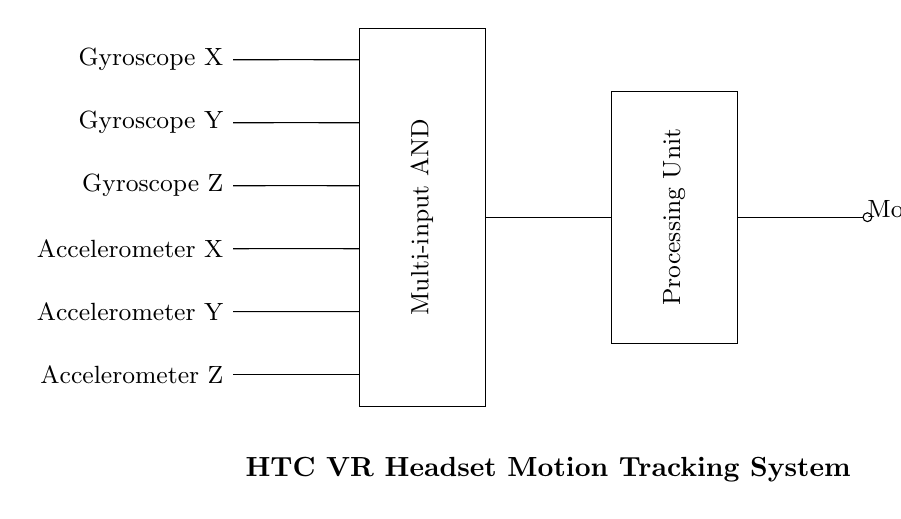What are the input signals provided to the multi-input AND gate? The circuit shows six input signals: Gyroscope X, Gyroscope Y, Gyroscope Z, Accelerometer X, Accelerometer Y, and Accelerometer Z, which are connected to the multi-input AND gate.
Answer: Gyroscope X, Gyroscope Y, Gyroscope Z, Accelerometer X, Accelerometer Y, Accelerometer Z What type of logic gate is represented in the circuit? The diagram contains a multi-input AND gate, which is identified by the labeled rectangle in the circuit that states its function.
Answer: Multi-input AND How many input signals are required to activate the output? In a multi-input AND gate, all inputs must be at a high state to yield a high output. Therefore, it requires all six input signals to be active to generate a motion output.
Answer: Six Which component processes the output from the multi-input AND gate? After the inputs are processed by the multi-input AND gate, the output is sent to the processing unit, which further handles the motion data. The processing unit is represented by another labeled rectangle in the circuit.
Answer: Processing unit What is the output of the processing unit? The output of the processing unit is labeled as motion data, referring to the combined information from the gyroscope and accelerometer inputs after processing.
Answer: Motion data 